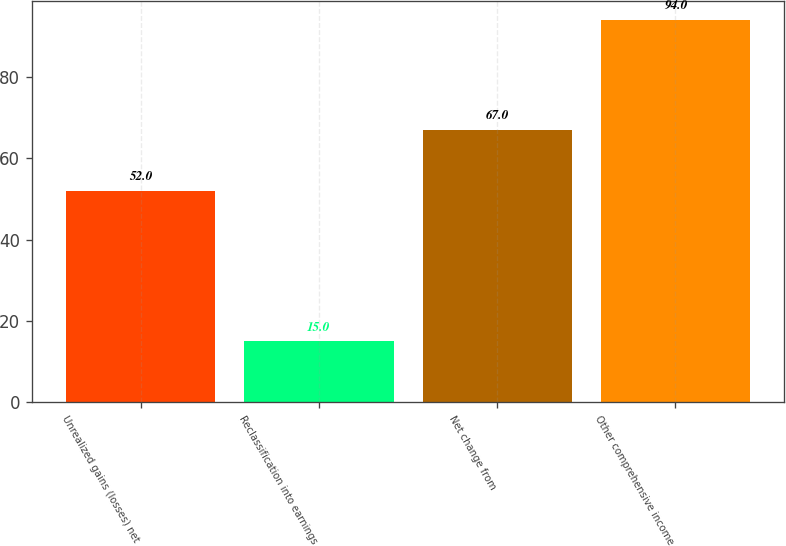<chart> <loc_0><loc_0><loc_500><loc_500><bar_chart><fcel>Unrealized gains (losses) net<fcel>Reclassification into earnings<fcel>Net change from<fcel>Other comprehensive income<nl><fcel>52<fcel>15<fcel>67<fcel>94<nl></chart> 